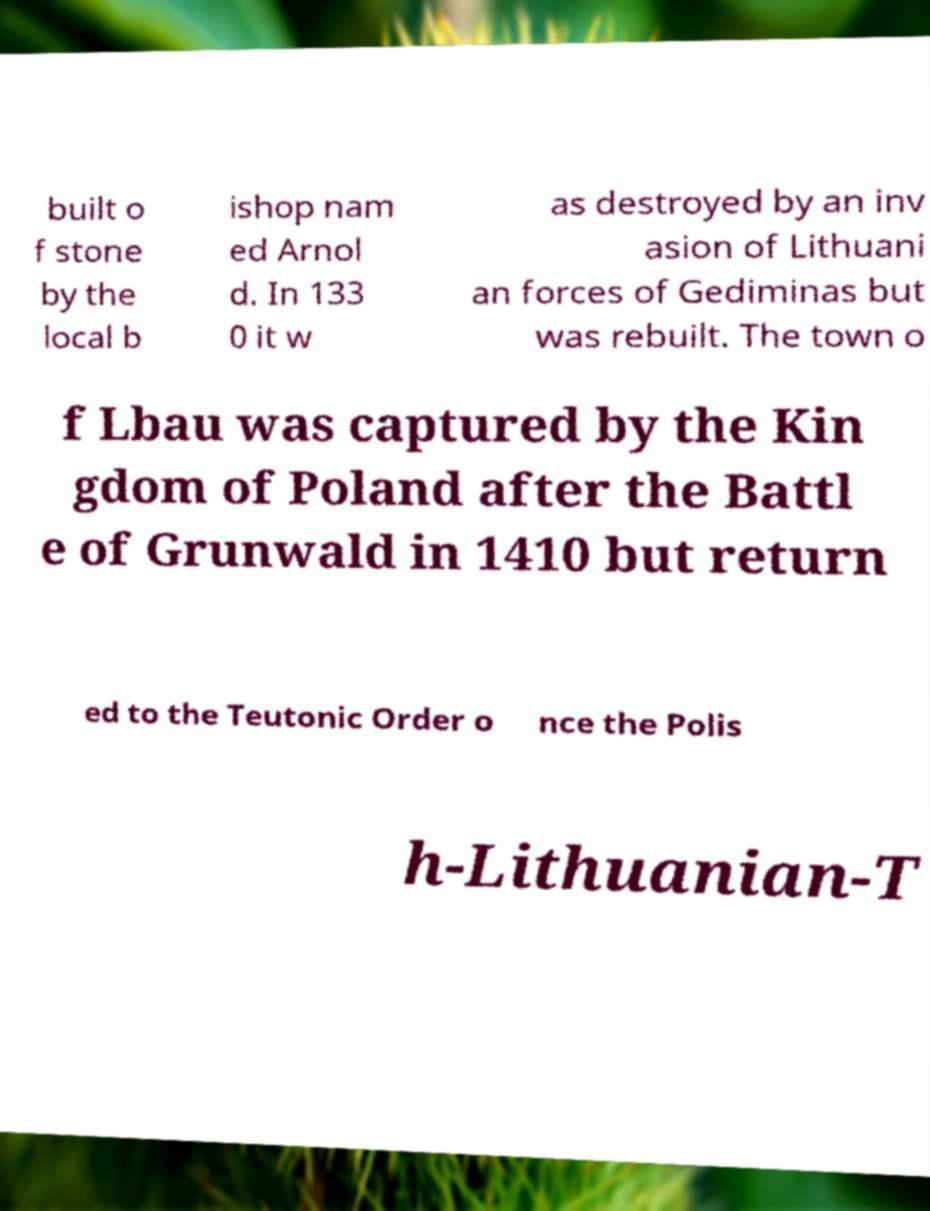I need the written content from this picture converted into text. Can you do that? built o f stone by the local b ishop nam ed Arnol d. In 133 0 it w as destroyed by an inv asion of Lithuani an forces of Gediminas but was rebuilt. The town o f Lbau was captured by the Kin gdom of Poland after the Battl e of Grunwald in 1410 but return ed to the Teutonic Order o nce the Polis h-Lithuanian-T 